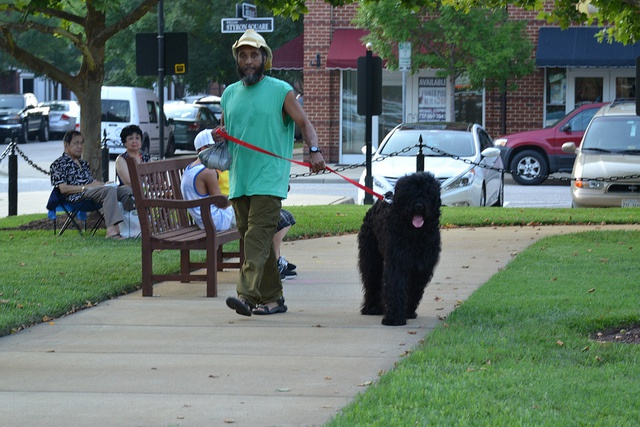Describe the objects in this image and their specific colors. I can see people in darkgreen, black, teal, gray, and turquoise tones, dog in darkgreen, black, gray, and darkgray tones, bench in darkgreen, black, gray, and green tones, car in darkgreen, white, lightblue, and darkgray tones, and car in darkgreen, gray, darkgray, and lightgray tones in this image. 